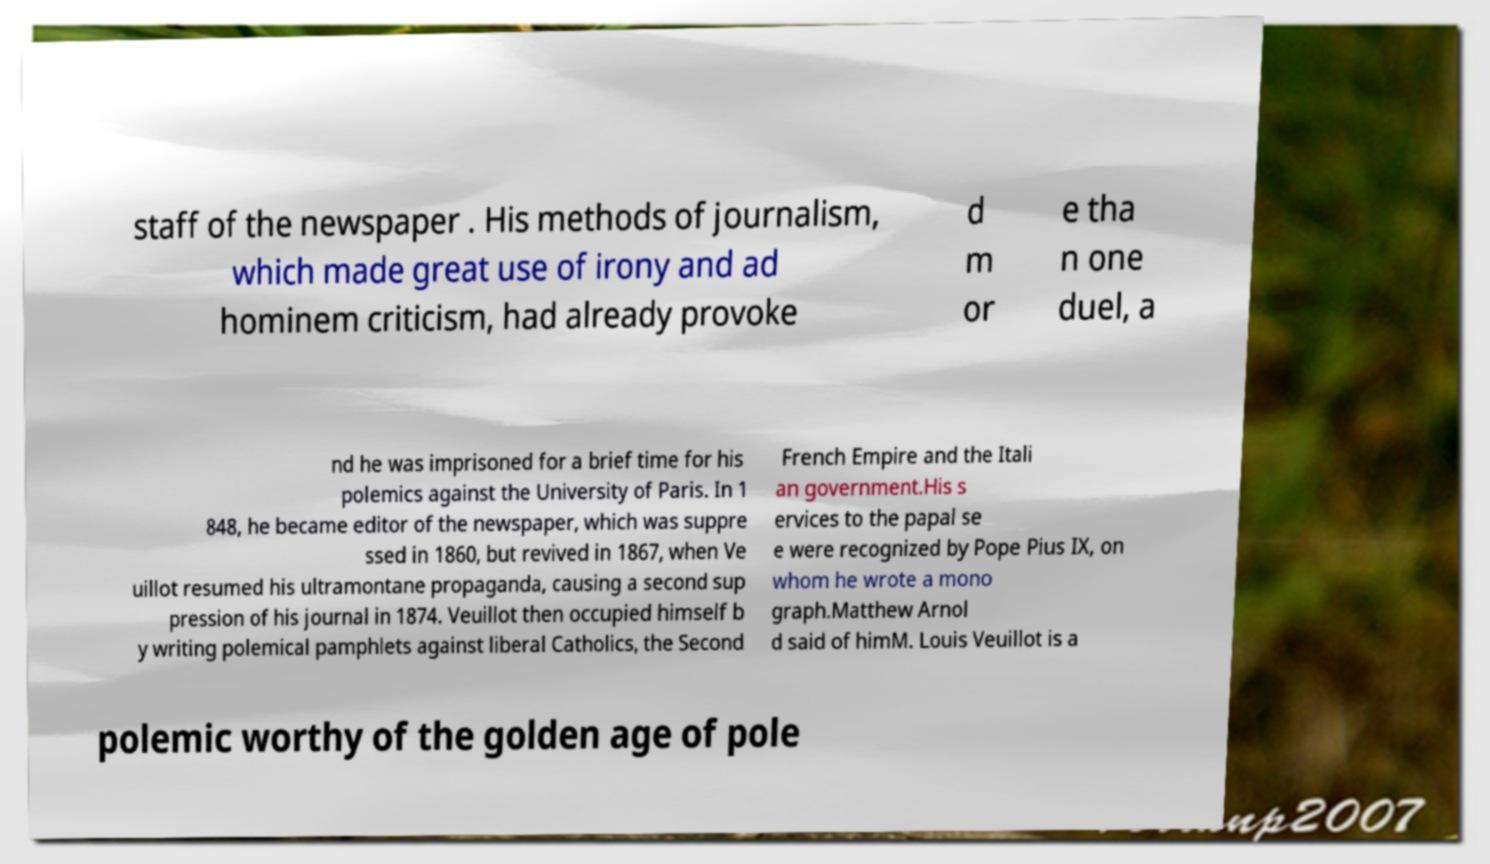Can you read and provide the text displayed in the image?This photo seems to have some interesting text. Can you extract and type it out for me? staff of the newspaper . His methods of journalism, which made great use of irony and ad hominem criticism, had already provoke d m or e tha n one duel, a nd he was imprisoned for a brief time for his polemics against the University of Paris. In 1 848, he became editor of the newspaper, which was suppre ssed in 1860, but revived in 1867, when Ve uillot resumed his ultramontane propaganda, causing a second sup pression of his journal in 1874. Veuillot then occupied himself b y writing polemical pamphlets against liberal Catholics, the Second French Empire and the Itali an government.His s ervices to the papal se e were recognized by Pope Pius IX, on whom he wrote a mono graph.Matthew Arnol d said of himM. Louis Veuillot is a polemic worthy of the golden age of pole 